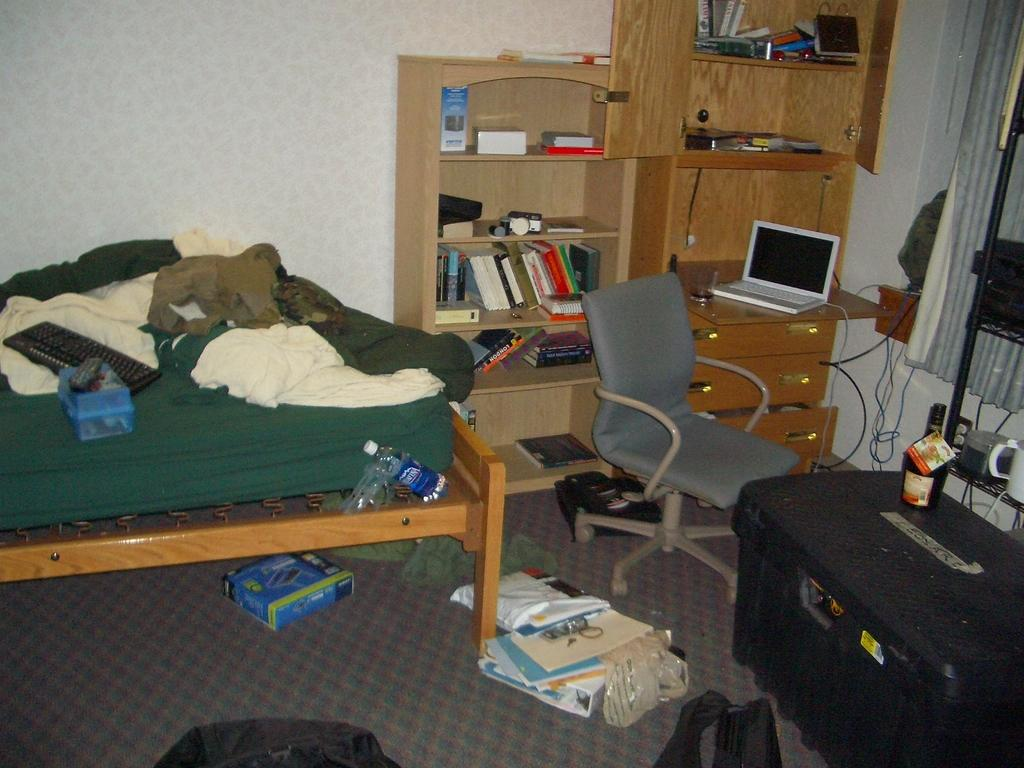What piece of furniture is present in the image? There is a bed in the image. What is on top of the bed? There are clothes on the bed. What electronic device is visible in the image? There is a laptop in the image. What type of storage furniture is present in the image? There is a bookshelf in the image. What other piece of furniture is present in the image? There is a chair in the image. What object is present in the image that is not furniture? There is a box in the image. What type of items can be seen on the floor in the image? There are books on the floor. What type of fork can be seen in the image? There is no fork present in the image. What type of recess can be seen in the image? There is no recess present in the image. 